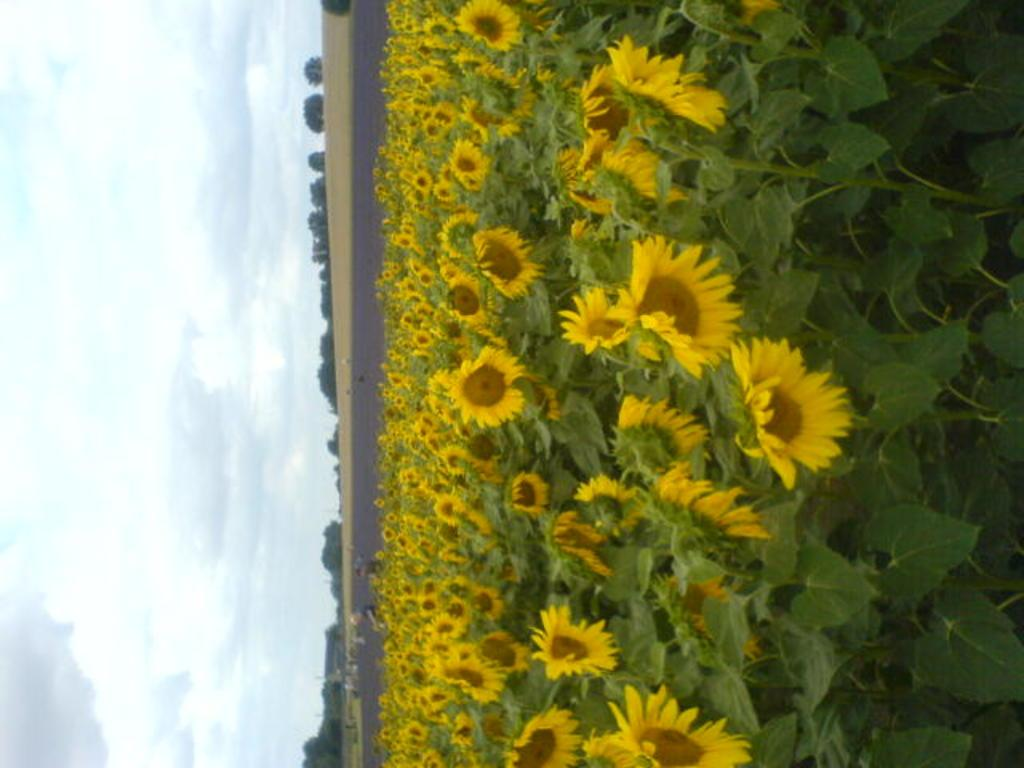What type of flowers are in the image? There are sunflowers in the image. What else is on the ground in the image besides the sunflowers? There are plants on the ground in the image. What can be seen in the background of the image? There are trees and clouds in the sky in the background of the image. What type of blood can be seen on the sunflowers in the image? There is no blood present in the image. 